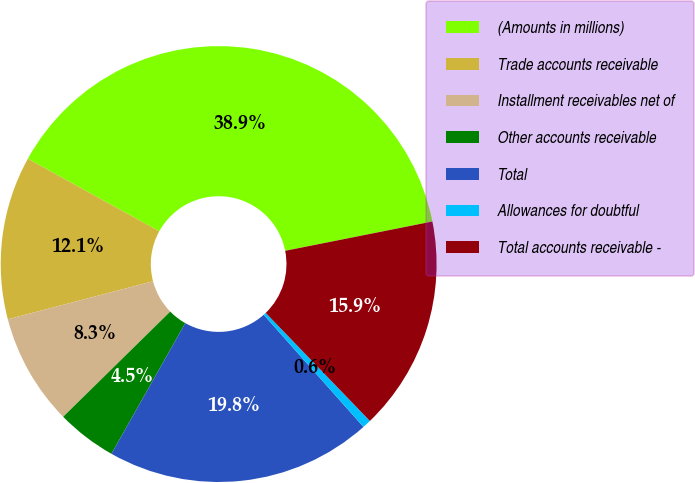<chart> <loc_0><loc_0><loc_500><loc_500><pie_chart><fcel>(Amounts in millions)<fcel>Trade accounts receivable<fcel>Installment receivables net of<fcel>Other accounts receivable<fcel>Total<fcel>Allowances for doubtful<fcel>Total accounts receivable -<nl><fcel>38.85%<fcel>12.1%<fcel>8.28%<fcel>4.46%<fcel>19.75%<fcel>0.64%<fcel>15.92%<nl></chart> 